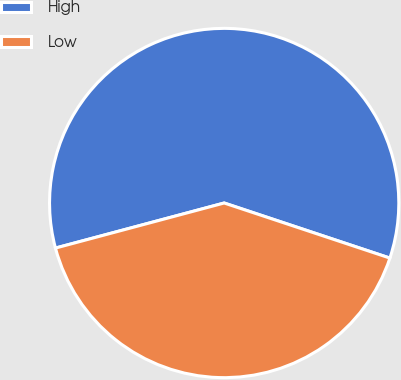Convert chart. <chart><loc_0><loc_0><loc_500><loc_500><pie_chart><fcel>High<fcel>Low<nl><fcel>59.26%<fcel>40.74%<nl></chart> 